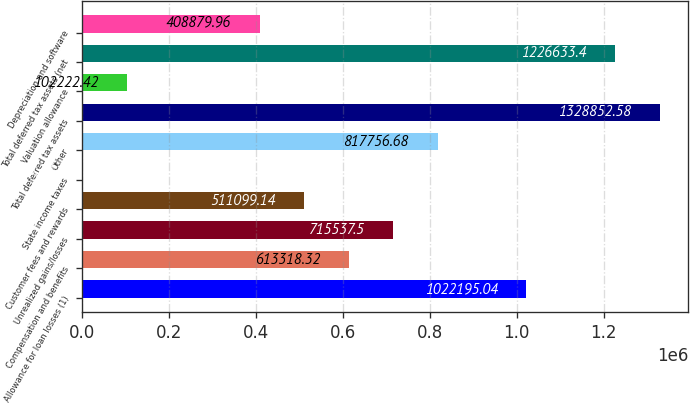<chart> <loc_0><loc_0><loc_500><loc_500><bar_chart><fcel>Allowance for loan losses (1)<fcel>Compensation and benefits<fcel>Unrealized gains/losses<fcel>Customer fees and rewards<fcel>State income taxes<fcel>Other<fcel>Total deferred tax assets<fcel>Valuation allowance<fcel>Total deferred tax assets (net<fcel>Depreciation and software<nl><fcel>1.0222e+06<fcel>613318<fcel>715538<fcel>511099<fcel>3.24<fcel>817757<fcel>1.32885e+06<fcel>102222<fcel>1.22663e+06<fcel>408880<nl></chart> 